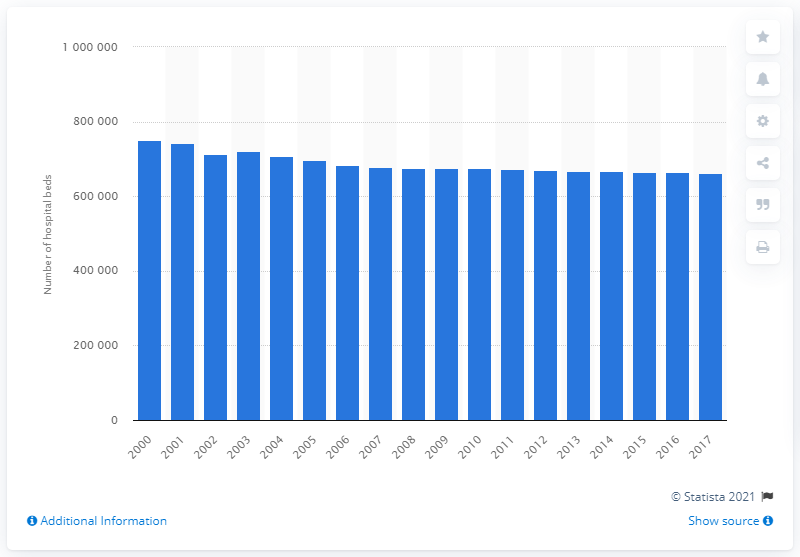Indicate a few pertinent items in this graphic. During the period between 2000 and 2017, there were a total of 661,448 hospital beds in Germany. In 2000, there were a total of 741,933 hospital beds available in Germany. 